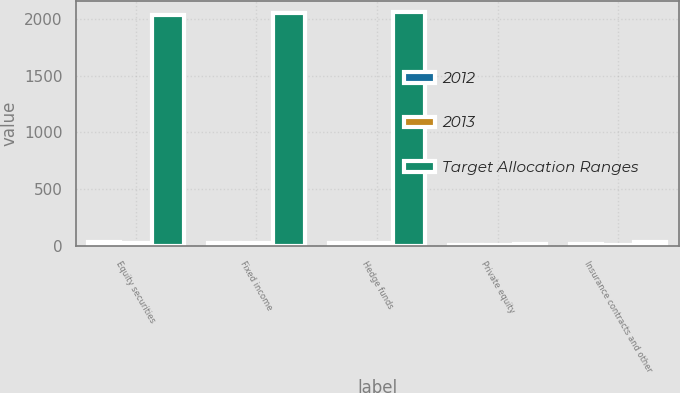<chart> <loc_0><loc_0><loc_500><loc_500><stacked_bar_chart><ecel><fcel>Equity securities<fcel>Fixed income<fcel>Hedge funds<fcel>Private equity<fcel>Insurance contracts and other<nl><fcel>2012<fcel>31.7<fcel>24.7<fcel>23.5<fcel>4.2<fcel>15.9<nl><fcel>2013<fcel>29.2<fcel>26.4<fcel>29.4<fcel>5.1<fcel>9.9<nl><fcel>Target Allocation Ranges<fcel>2040<fcel>2050<fcel>2060<fcel>15<fcel>30<nl></chart> 